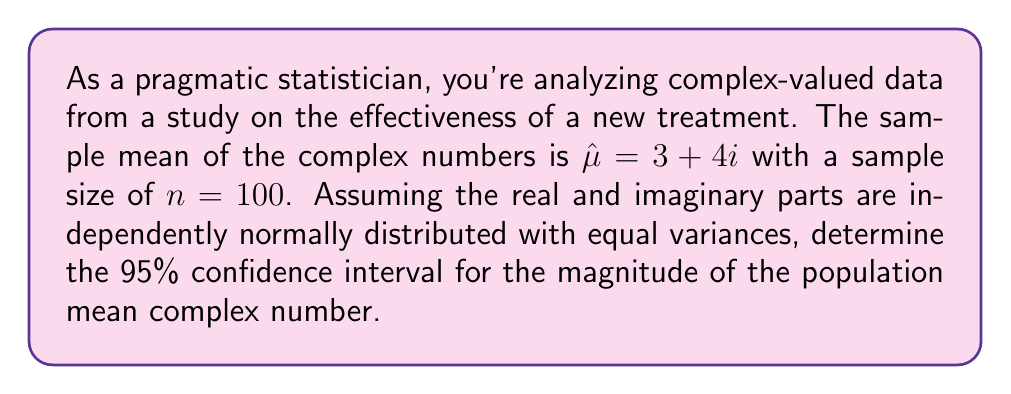Solve this math problem. Let's approach this step-by-step:

1) The magnitude of a complex number $a + bi$ is given by $\sqrt{a^2 + b^2}$.

2) For our sample mean $\hat{\mu} = 3 + 4i$, the magnitude is:
   $$|\hat{\mu}| = \sqrt{3^2 + 4^2} = \sqrt{25} = 5$$

3) The variance of the magnitude can be approximated using the delta method:
   $$\text{Var}(|\hat{\mu}|) \approx \frac{\text{Var}(\text{Re}(\hat{\mu})) + \text{Var}(\text{Im}(\hat{\mu}))}{4n|\hat{\mu}|^2}$$

4) Assuming equal variances $\sigma^2$ for real and imaginary parts:
   $$\text{Var}(|\hat{\mu}|) \approx \frac{\sigma^2 + \sigma^2}{4n|\hat{\mu}|^2} = \frac{\sigma^2}{2n|\hat{\mu}|^2}$$

5) We don't know $\sigma^2$, but we can estimate it from the sample variance of the real and imaginary parts. Let's assume this estimate is $s^2$.

6) The standard error of $|\hat{\mu}|$ is then:
   $$SE(|\hat{\mu}|) = \sqrt{\frac{s^2}{2n|\hat{\mu}|^2}}$$

7) For a 95% confidence interval, we use the z-score of 1.96 (assuming large n):
   $$CI = |\hat{\mu}| \pm 1.96 \cdot SE(|\hat{\mu}|)$$

8) Without the actual value of $s^2$, we can't calculate the exact interval. However, the formula for the confidence interval would be:
   $$5 \pm 1.96 \cdot \sqrt{\frac{s^2}{2 \cdot 100 \cdot 5^2}}$$

9) Simplifying:
   $$5 \pm 0.0392 \cdot \sqrt{s^2}$$
Answer: $5 \pm 0.0392 \sqrt{s^2}$ 